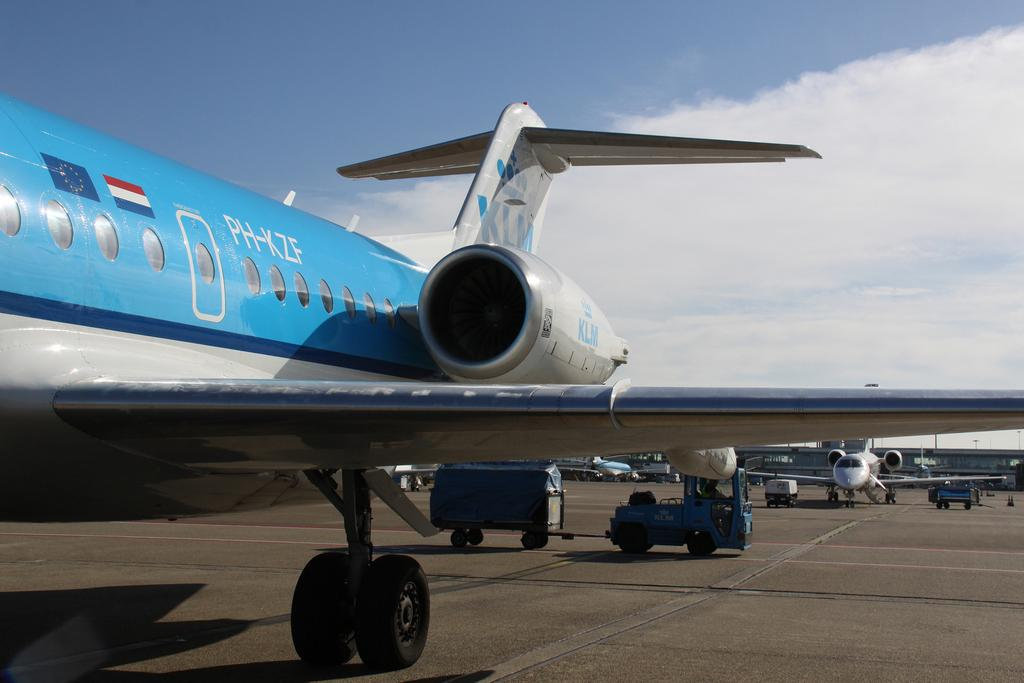What is the main subject of the image? The main subject of the image is an airplane. What features can be seen on the airplane? The airplane has flags and text on it. Are there any other airplanes visible in the image? Yes, there are other airplanes visible in the image. What type of building can be seen in the image? There is a building that resembles an airport in the image. What type of ear is visible on the airplane in the image? There is no ear present on the airplane in the image. Can you tell me how many hospitals are visible in the image? There are no hospitals visible in the image; it features airplanes and an airport-like building. 